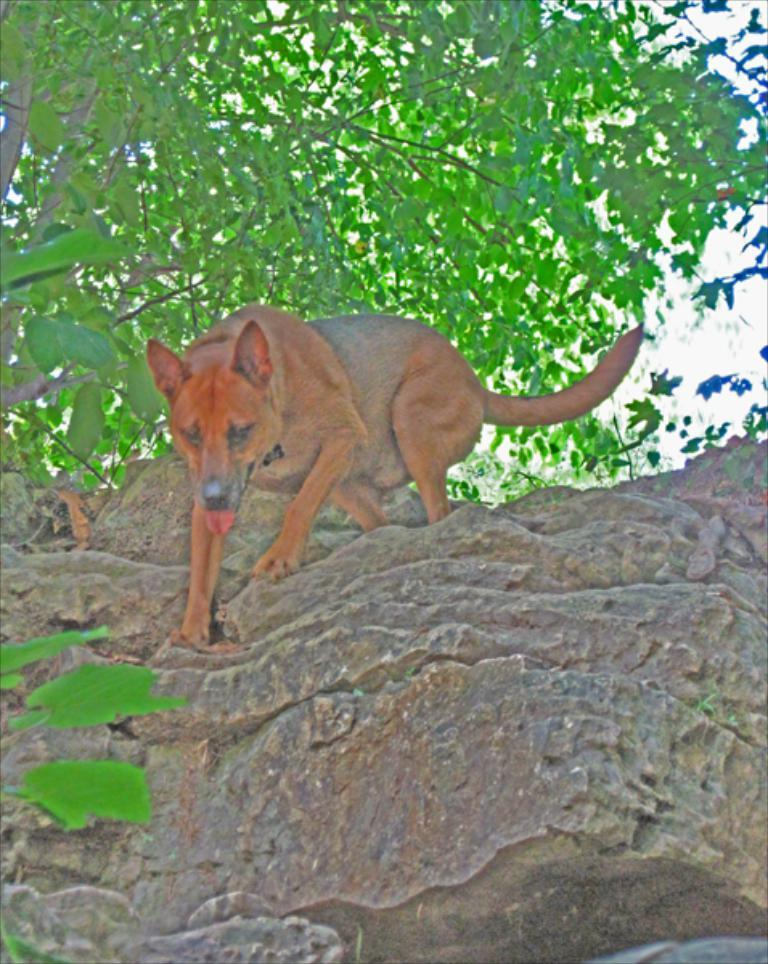What type of animal is in the image? There is a dog in the image. What is the dog standing on? The dog is standing on a stone. What can be seen in the background of the image? There are trees in the background of the image. What type of agreement is being discussed in the image? There is no discussion or agreement present in the image; it features a dog standing on a stone with trees in the background. 